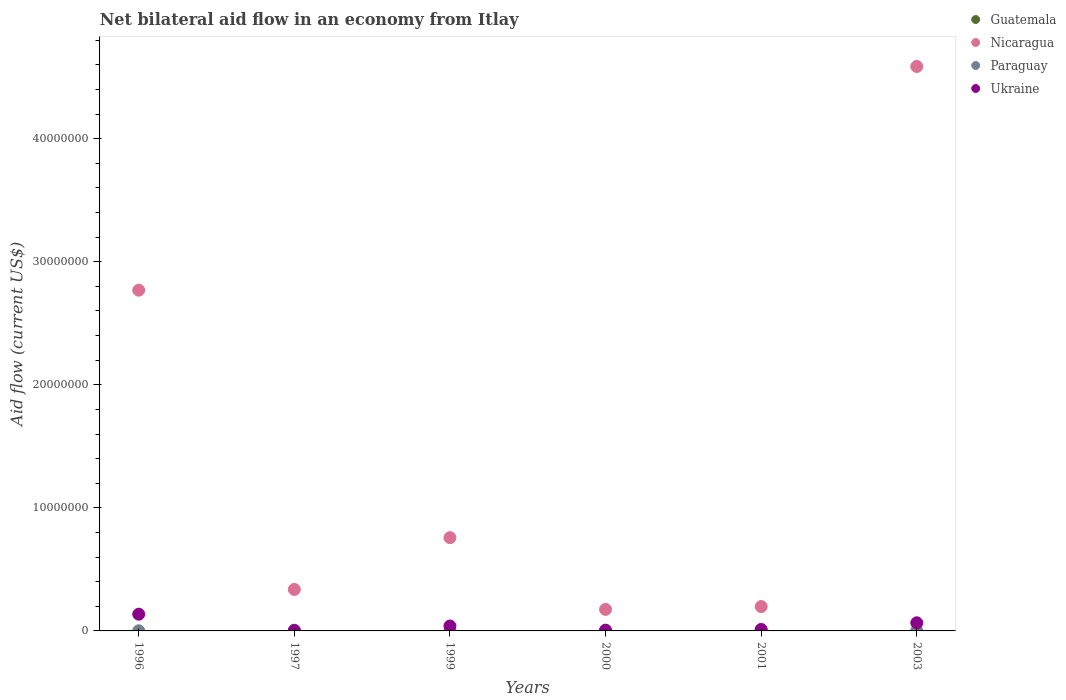How many different coloured dotlines are there?
Provide a succinct answer. 3. Is the number of dotlines equal to the number of legend labels?
Keep it short and to the point. No. What is the net bilateral aid flow in Paraguay in 1996?
Keep it short and to the point. 10000. In which year was the net bilateral aid flow in Ukraine maximum?
Make the answer very short. 1996. What is the total net bilateral aid flow in Nicaragua in the graph?
Provide a succinct answer. 8.82e+07. What is the difference between the net bilateral aid flow in Ukraine in 2003 and the net bilateral aid flow in Guatemala in 1997?
Give a very brief answer. 6.60e+05. What is the average net bilateral aid flow in Nicaragua per year?
Your response must be concise. 1.47e+07. In the year 1999, what is the difference between the net bilateral aid flow in Paraguay and net bilateral aid flow in Nicaragua?
Keep it short and to the point. -7.56e+06. In how many years, is the net bilateral aid flow in Nicaragua greater than 32000000 US$?
Ensure brevity in your answer.  1. Is the net bilateral aid flow in Paraguay in 1996 less than that in 2001?
Provide a succinct answer. Yes. Is the difference between the net bilateral aid flow in Paraguay in 2001 and 2003 greater than the difference between the net bilateral aid flow in Nicaragua in 2001 and 2003?
Provide a short and direct response. Yes. What is the difference between the highest and the second highest net bilateral aid flow in Nicaragua?
Keep it short and to the point. 1.82e+07. What is the difference between the highest and the lowest net bilateral aid flow in Nicaragua?
Make the answer very short. 4.41e+07. Is the sum of the net bilateral aid flow in Paraguay in 1999 and 2000 greater than the maximum net bilateral aid flow in Nicaragua across all years?
Keep it short and to the point. No. Is it the case that in every year, the sum of the net bilateral aid flow in Guatemala and net bilateral aid flow in Ukraine  is greater than the sum of net bilateral aid flow in Paraguay and net bilateral aid flow in Nicaragua?
Provide a short and direct response. No. Is the net bilateral aid flow in Nicaragua strictly greater than the net bilateral aid flow in Guatemala over the years?
Keep it short and to the point. Yes. How many dotlines are there?
Your answer should be compact. 3. What is the difference between two consecutive major ticks on the Y-axis?
Offer a terse response. 1.00e+07. Does the graph contain any zero values?
Ensure brevity in your answer.  Yes. What is the title of the graph?
Give a very brief answer. Net bilateral aid flow in an economy from Itlay. What is the label or title of the Y-axis?
Offer a very short reply. Aid flow (current US$). What is the Aid flow (current US$) of Guatemala in 1996?
Provide a short and direct response. 0. What is the Aid flow (current US$) of Nicaragua in 1996?
Keep it short and to the point. 2.77e+07. What is the Aid flow (current US$) in Paraguay in 1996?
Make the answer very short. 10000. What is the Aid flow (current US$) of Ukraine in 1996?
Provide a succinct answer. 1.36e+06. What is the Aid flow (current US$) in Guatemala in 1997?
Offer a terse response. 0. What is the Aid flow (current US$) of Nicaragua in 1997?
Keep it short and to the point. 3.37e+06. What is the Aid flow (current US$) of Paraguay in 1997?
Ensure brevity in your answer.  6.00e+04. What is the Aid flow (current US$) of Ukraine in 1997?
Provide a succinct answer. 3.00e+04. What is the Aid flow (current US$) of Nicaragua in 1999?
Your answer should be very brief. 7.58e+06. What is the Aid flow (current US$) of Paraguay in 1999?
Keep it short and to the point. 2.00e+04. What is the Aid flow (current US$) of Nicaragua in 2000?
Make the answer very short. 1.75e+06. What is the Aid flow (current US$) of Ukraine in 2000?
Your answer should be very brief. 6.00e+04. What is the Aid flow (current US$) in Guatemala in 2001?
Ensure brevity in your answer.  0. What is the Aid flow (current US$) in Nicaragua in 2001?
Your answer should be very brief. 1.98e+06. What is the Aid flow (current US$) of Ukraine in 2001?
Your response must be concise. 1.20e+05. What is the Aid flow (current US$) in Nicaragua in 2003?
Ensure brevity in your answer.  4.59e+07. What is the Aid flow (current US$) in Paraguay in 2003?
Make the answer very short. 2.00e+04. What is the Aid flow (current US$) of Ukraine in 2003?
Your response must be concise. 6.60e+05. Across all years, what is the maximum Aid flow (current US$) of Nicaragua?
Your response must be concise. 4.59e+07. Across all years, what is the maximum Aid flow (current US$) in Paraguay?
Keep it short and to the point. 6.00e+04. Across all years, what is the maximum Aid flow (current US$) in Ukraine?
Your answer should be very brief. 1.36e+06. Across all years, what is the minimum Aid flow (current US$) of Nicaragua?
Provide a succinct answer. 1.75e+06. Across all years, what is the minimum Aid flow (current US$) of Paraguay?
Make the answer very short. 10000. What is the total Aid flow (current US$) of Guatemala in the graph?
Offer a terse response. 0. What is the total Aid flow (current US$) in Nicaragua in the graph?
Your answer should be very brief. 8.82e+07. What is the total Aid flow (current US$) in Paraguay in the graph?
Your answer should be very brief. 1.90e+05. What is the total Aid flow (current US$) of Ukraine in the graph?
Provide a succinct answer. 2.63e+06. What is the difference between the Aid flow (current US$) of Nicaragua in 1996 and that in 1997?
Offer a very short reply. 2.43e+07. What is the difference between the Aid flow (current US$) in Ukraine in 1996 and that in 1997?
Your response must be concise. 1.33e+06. What is the difference between the Aid flow (current US$) in Nicaragua in 1996 and that in 1999?
Make the answer very short. 2.01e+07. What is the difference between the Aid flow (current US$) of Paraguay in 1996 and that in 1999?
Your answer should be compact. -10000. What is the difference between the Aid flow (current US$) of Ukraine in 1996 and that in 1999?
Give a very brief answer. 9.60e+05. What is the difference between the Aid flow (current US$) of Nicaragua in 1996 and that in 2000?
Provide a succinct answer. 2.59e+07. What is the difference between the Aid flow (current US$) of Paraguay in 1996 and that in 2000?
Keep it short and to the point. -2.00e+04. What is the difference between the Aid flow (current US$) in Ukraine in 1996 and that in 2000?
Keep it short and to the point. 1.30e+06. What is the difference between the Aid flow (current US$) of Nicaragua in 1996 and that in 2001?
Give a very brief answer. 2.57e+07. What is the difference between the Aid flow (current US$) of Ukraine in 1996 and that in 2001?
Offer a very short reply. 1.24e+06. What is the difference between the Aid flow (current US$) of Nicaragua in 1996 and that in 2003?
Ensure brevity in your answer.  -1.82e+07. What is the difference between the Aid flow (current US$) of Nicaragua in 1997 and that in 1999?
Give a very brief answer. -4.21e+06. What is the difference between the Aid flow (current US$) of Paraguay in 1997 and that in 1999?
Your answer should be compact. 4.00e+04. What is the difference between the Aid flow (current US$) of Ukraine in 1997 and that in 1999?
Give a very brief answer. -3.70e+05. What is the difference between the Aid flow (current US$) in Nicaragua in 1997 and that in 2000?
Give a very brief answer. 1.62e+06. What is the difference between the Aid flow (current US$) in Ukraine in 1997 and that in 2000?
Provide a succinct answer. -3.00e+04. What is the difference between the Aid flow (current US$) in Nicaragua in 1997 and that in 2001?
Your response must be concise. 1.39e+06. What is the difference between the Aid flow (current US$) of Paraguay in 1997 and that in 2001?
Your answer should be very brief. 10000. What is the difference between the Aid flow (current US$) of Nicaragua in 1997 and that in 2003?
Keep it short and to the point. -4.25e+07. What is the difference between the Aid flow (current US$) in Paraguay in 1997 and that in 2003?
Provide a succinct answer. 4.00e+04. What is the difference between the Aid flow (current US$) of Ukraine in 1997 and that in 2003?
Your answer should be compact. -6.30e+05. What is the difference between the Aid flow (current US$) of Nicaragua in 1999 and that in 2000?
Give a very brief answer. 5.83e+06. What is the difference between the Aid flow (current US$) in Paraguay in 1999 and that in 2000?
Make the answer very short. -10000. What is the difference between the Aid flow (current US$) of Ukraine in 1999 and that in 2000?
Ensure brevity in your answer.  3.40e+05. What is the difference between the Aid flow (current US$) in Nicaragua in 1999 and that in 2001?
Make the answer very short. 5.60e+06. What is the difference between the Aid flow (current US$) in Paraguay in 1999 and that in 2001?
Provide a short and direct response. -3.00e+04. What is the difference between the Aid flow (current US$) of Ukraine in 1999 and that in 2001?
Offer a very short reply. 2.80e+05. What is the difference between the Aid flow (current US$) of Nicaragua in 1999 and that in 2003?
Offer a very short reply. -3.83e+07. What is the difference between the Aid flow (current US$) of Paraguay in 1999 and that in 2003?
Provide a short and direct response. 0. What is the difference between the Aid flow (current US$) in Ukraine in 1999 and that in 2003?
Ensure brevity in your answer.  -2.60e+05. What is the difference between the Aid flow (current US$) in Nicaragua in 2000 and that in 2003?
Offer a very short reply. -4.41e+07. What is the difference between the Aid flow (current US$) in Ukraine in 2000 and that in 2003?
Offer a terse response. -6.00e+05. What is the difference between the Aid flow (current US$) in Nicaragua in 2001 and that in 2003?
Offer a very short reply. -4.39e+07. What is the difference between the Aid flow (current US$) in Paraguay in 2001 and that in 2003?
Your response must be concise. 3.00e+04. What is the difference between the Aid flow (current US$) of Ukraine in 2001 and that in 2003?
Your response must be concise. -5.40e+05. What is the difference between the Aid flow (current US$) in Nicaragua in 1996 and the Aid flow (current US$) in Paraguay in 1997?
Provide a succinct answer. 2.76e+07. What is the difference between the Aid flow (current US$) of Nicaragua in 1996 and the Aid flow (current US$) of Ukraine in 1997?
Keep it short and to the point. 2.77e+07. What is the difference between the Aid flow (current US$) of Nicaragua in 1996 and the Aid flow (current US$) of Paraguay in 1999?
Give a very brief answer. 2.77e+07. What is the difference between the Aid flow (current US$) in Nicaragua in 1996 and the Aid flow (current US$) in Ukraine in 1999?
Offer a very short reply. 2.73e+07. What is the difference between the Aid flow (current US$) in Paraguay in 1996 and the Aid flow (current US$) in Ukraine in 1999?
Your response must be concise. -3.90e+05. What is the difference between the Aid flow (current US$) in Nicaragua in 1996 and the Aid flow (current US$) in Paraguay in 2000?
Ensure brevity in your answer.  2.77e+07. What is the difference between the Aid flow (current US$) in Nicaragua in 1996 and the Aid flow (current US$) in Ukraine in 2000?
Offer a terse response. 2.76e+07. What is the difference between the Aid flow (current US$) in Paraguay in 1996 and the Aid flow (current US$) in Ukraine in 2000?
Provide a short and direct response. -5.00e+04. What is the difference between the Aid flow (current US$) of Nicaragua in 1996 and the Aid flow (current US$) of Paraguay in 2001?
Give a very brief answer. 2.76e+07. What is the difference between the Aid flow (current US$) in Nicaragua in 1996 and the Aid flow (current US$) in Ukraine in 2001?
Provide a succinct answer. 2.76e+07. What is the difference between the Aid flow (current US$) in Nicaragua in 1996 and the Aid flow (current US$) in Paraguay in 2003?
Provide a short and direct response. 2.77e+07. What is the difference between the Aid flow (current US$) of Nicaragua in 1996 and the Aid flow (current US$) of Ukraine in 2003?
Give a very brief answer. 2.70e+07. What is the difference between the Aid flow (current US$) in Paraguay in 1996 and the Aid flow (current US$) in Ukraine in 2003?
Provide a succinct answer. -6.50e+05. What is the difference between the Aid flow (current US$) in Nicaragua in 1997 and the Aid flow (current US$) in Paraguay in 1999?
Your answer should be compact. 3.35e+06. What is the difference between the Aid flow (current US$) in Nicaragua in 1997 and the Aid flow (current US$) in Ukraine in 1999?
Your answer should be very brief. 2.97e+06. What is the difference between the Aid flow (current US$) of Paraguay in 1997 and the Aid flow (current US$) of Ukraine in 1999?
Offer a very short reply. -3.40e+05. What is the difference between the Aid flow (current US$) of Nicaragua in 1997 and the Aid flow (current US$) of Paraguay in 2000?
Provide a short and direct response. 3.34e+06. What is the difference between the Aid flow (current US$) of Nicaragua in 1997 and the Aid flow (current US$) of Ukraine in 2000?
Offer a very short reply. 3.31e+06. What is the difference between the Aid flow (current US$) in Paraguay in 1997 and the Aid flow (current US$) in Ukraine in 2000?
Provide a short and direct response. 0. What is the difference between the Aid flow (current US$) of Nicaragua in 1997 and the Aid flow (current US$) of Paraguay in 2001?
Your answer should be compact. 3.32e+06. What is the difference between the Aid flow (current US$) of Nicaragua in 1997 and the Aid flow (current US$) of Ukraine in 2001?
Your response must be concise. 3.25e+06. What is the difference between the Aid flow (current US$) in Nicaragua in 1997 and the Aid flow (current US$) in Paraguay in 2003?
Give a very brief answer. 3.35e+06. What is the difference between the Aid flow (current US$) of Nicaragua in 1997 and the Aid flow (current US$) of Ukraine in 2003?
Offer a terse response. 2.71e+06. What is the difference between the Aid flow (current US$) of Paraguay in 1997 and the Aid flow (current US$) of Ukraine in 2003?
Offer a very short reply. -6.00e+05. What is the difference between the Aid flow (current US$) in Nicaragua in 1999 and the Aid flow (current US$) in Paraguay in 2000?
Your answer should be very brief. 7.55e+06. What is the difference between the Aid flow (current US$) of Nicaragua in 1999 and the Aid flow (current US$) of Ukraine in 2000?
Your response must be concise. 7.52e+06. What is the difference between the Aid flow (current US$) of Nicaragua in 1999 and the Aid flow (current US$) of Paraguay in 2001?
Offer a terse response. 7.53e+06. What is the difference between the Aid flow (current US$) of Nicaragua in 1999 and the Aid flow (current US$) of Ukraine in 2001?
Provide a short and direct response. 7.46e+06. What is the difference between the Aid flow (current US$) of Paraguay in 1999 and the Aid flow (current US$) of Ukraine in 2001?
Offer a terse response. -1.00e+05. What is the difference between the Aid flow (current US$) of Nicaragua in 1999 and the Aid flow (current US$) of Paraguay in 2003?
Offer a very short reply. 7.56e+06. What is the difference between the Aid flow (current US$) in Nicaragua in 1999 and the Aid flow (current US$) in Ukraine in 2003?
Keep it short and to the point. 6.92e+06. What is the difference between the Aid flow (current US$) in Paraguay in 1999 and the Aid flow (current US$) in Ukraine in 2003?
Give a very brief answer. -6.40e+05. What is the difference between the Aid flow (current US$) of Nicaragua in 2000 and the Aid flow (current US$) of Paraguay in 2001?
Offer a very short reply. 1.70e+06. What is the difference between the Aid flow (current US$) in Nicaragua in 2000 and the Aid flow (current US$) in Ukraine in 2001?
Provide a short and direct response. 1.63e+06. What is the difference between the Aid flow (current US$) in Paraguay in 2000 and the Aid flow (current US$) in Ukraine in 2001?
Offer a very short reply. -9.00e+04. What is the difference between the Aid flow (current US$) in Nicaragua in 2000 and the Aid flow (current US$) in Paraguay in 2003?
Offer a terse response. 1.73e+06. What is the difference between the Aid flow (current US$) in Nicaragua in 2000 and the Aid flow (current US$) in Ukraine in 2003?
Your answer should be very brief. 1.09e+06. What is the difference between the Aid flow (current US$) in Paraguay in 2000 and the Aid flow (current US$) in Ukraine in 2003?
Make the answer very short. -6.30e+05. What is the difference between the Aid flow (current US$) of Nicaragua in 2001 and the Aid flow (current US$) of Paraguay in 2003?
Ensure brevity in your answer.  1.96e+06. What is the difference between the Aid flow (current US$) in Nicaragua in 2001 and the Aid flow (current US$) in Ukraine in 2003?
Keep it short and to the point. 1.32e+06. What is the difference between the Aid flow (current US$) of Paraguay in 2001 and the Aid flow (current US$) of Ukraine in 2003?
Provide a short and direct response. -6.10e+05. What is the average Aid flow (current US$) in Guatemala per year?
Keep it short and to the point. 0. What is the average Aid flow (current US$) of Nicaragua per year?
Your response must be concise. 1.47e+07. What is the average Aid flow (current US$) of Paraguay per year?
Ensure brevity in your answer.  3.17e+04. What is the average Aid flow (current US$) of Ukraine per year?
Offer a terse response. 4.38e+05. In the year 1996, what is the difference between the Aid flow (current US$) of Nicaragua and Aid flow (current US$) of Paraguay?
Provide a succinct answer. 2.77e+07. In the year 1996, what is the difference between the Aid flow (current US$) of Nicaragua and Aid flow (current US$) of Ukraine?
Provide a succinct answer. 2.63e+07. In the year 1996, what is the difference between the Aid flow (current US$) in Paraguay and Aid flow (current US$) in Ukraine?
Your answer should be compact. -1.35e+06. In the year 1997, what is the difference between the Aid flow (current US$) in Nicaragua and Aid flow (current US$) in Paraguay?
Your answer should be compact. 3.31e+06. In the year 1997, what is the difference between the Aid flow (current US$) in Nicaragua and Aid flow (current US$) in Ukraine?
Make the answer very short. 3.34e+06. In the year 1999, what is the difference between the Aid flow (current US$) in Nicaragua and Aid flow (current US$) in Paraguay?
Your response must be concise. 7.56e+06. In the year 1999, what is the difference between the Aid flow (current US$) of Nicaragua and Aid flow (current US$) of Ukraine?
Provide a succinct answer. 7.18e+06. In the year 1999, what is the difference between the Aid flow (current US$) in Paraguay and Aid flow (current US$) in Ukraine?
Provide a short and direct response. -3.80e+05. In the year 2000, what is the difference between the Aid flow (current US$) of Nicaragua and Aid flow (current US$) of Paraguay?
Your answer should be compact. 1.72e+06. In the year 2000, what is the difference between the Aid flow (current US$) of Nicaragua and Aid flow (current US$) of Ukraine?
Give a very brief answer. 1.69e+06. In the year 2001, what is the difference between the Aid flow (current US$) of Nicaragua and Aid flow (current US$) of Paraguay?
Offer a very short reply. 1.93e+06. In the year 2001, what is the difference between the Aid flow (current US$) of Nicaragua and Aid flow (current US$) of Ukraine?
Give a very brief answer. 1.86e+06. In the year 2003, what is the difference between the Aid flow (current US$) in Nicaragua and Aid flow (current US$) in Paraguay?
Provide a short and direct response. 4.58e+07. In the year 2003, what is the difference between the Aid flow (current US$) in Nicaragua and Aid flow (current US$) in Ukraine?
Ensure brevity in your answer.  4.52e+07. In the year 2003, what is the difference between the Aid flow (current US$) in Paraguay and Aid flow (current US$) in Ukraine?
Provide a short and direct response. -6.40e+05. What is the ratio of the Aid flow (current US$) in Nicaragua in 1996 to that in 1997?
Provide a succinct answer. 8.22. What is the ratio of the Aid flow (current US$) of Ukraine in 1996 to that in 1997?
Keep it short and to the point. 45.33. What is the ratio of the Aid flow (current US$) in Nicaragua in 1996 to that in 1999?
Your answer should be compact. 3.65. What is the ratio of the Aid flow (current US$) of Paraguay in 1996 to that in 1999?
Offer a terse response. 0.5. What is the ratio of the Aid flow (current US$) in Nicaragua in 1996 to that in 2000?
Provide a succinct answer. 15.82. What is the ratio of the Aid flow (current US$) of Paraguay in 1996 to that in 2000?
Give a very brief answer. 0.33. What is the ratio of the Aid flow (current US$) in Ukraine in 1996 to that in 2000?
Make the answer very short. 22.67. What is the ratio of the Aid flow (current US$) in Nicaragua in 1996 to that in 2001?
Keep it short and to the point. 13.98. What is the ratio of the Aid flow (current US$) in Ukraine in 1996 to that in 2001?
Make the answer very short. 11.33. What is the ratio of the Aid flow (current US$) in Nicaragua in 1996 to that in 2003?
Provide a short and direct response. 0.6. What is the ratio of the Aid flow (current US$) of Ukraine in 1996 to that in 2003?
Keep it short and to the point. 2.06. What is the ratio of the Aid flow (current US$) of Nicaragua in 1997 to that in 1999?
Your response must be concise. 0.44. What is the ratio of the Aid flow (current US$) of Ukraine in 1997 to that in 1999?
Make the answer very short. 0.07. What is the ratio of the Aid flow (current US$) of Nicaragua in 1997 to that in 2000?
Keep it short and to the point. 1.93. What is the ratio of the Aid flow (current US$) in Nicaragua in 1997 to that in 2001?
Give a very brief answer. 1.7. What is the ratio of the Aid flow (current US$) of Paraguay in 1997 to that in 2001?
Provide a succinct answer. 1.2. What is the ratio of the Aid flow (current US$) in Ukraine in 1997 to that in 2001?
Provide a short and direct response. 0.25. What is the ratio of the Aid flow (current US$) of Nicaragua in 1997 to that in 2003?
Ensure brevity in your answer.  0.07. What is the ratio of the Aid flow (current US$) of Ukraine in 1997 to that in 2003?
Offer a very short reply. 0.05. What is the ratio of the Aid flow (current US$) of Nicaragua in 1999 to that in 2000?
Your answer should be compact. 4.33. What is the ratio of the Aid flow (current US$) of Paraguay in 1999 to that in 2000?
Ensure brevity in your answer.  0.67. What is the ratio of the Aid flow (current US$) of Nicaragua in 1999 to that in 2001?
Ensure brevity in your answer.  3.83. What is the ratio of the Aid flow (current US$) of Nicaragua in 1999 to that in 2003?
Ensure brevity in your answer.  0.17. What is the ratio of the Aid flow (current US$) of Ukraine in 1999 to that in 2003?
Keep it short and to the point. 0.61. What is the ratio of the Aid flow (current US$) of Nicaragua in 2000 to that in 2001?
Offer a terse response. 0.88. What is the ratio of the Aid flow (current US$) of Paraguay in 2000 to that in 2001?
Keep it short and to the point. 0.6. What is the ratio of the Aid flow (current US$) in Nicaragua in 2000 to that in 2003?
Provide a succinct answer. 0.04. What is the ratio of the Aid flow (current US$) of Paraguay in 2000 to that in 2003?
Give a very brief answer. 1.5. What is the ratio of the Aid flow (current US$) in Ukraine in 2000 to that in 2003?
Your answer should be compact. 0.09. What is the ratio of the Aid flow (current US$) in Nicaragua in 2001 to that in 2003?
Your answer should be compact. 0.04. What is the ratio of the Aid flow (current US$) of Paraguay in 2001 to that in 2003?
Provide a short and direct response. 2.5. What is the ratio of the Aid flow (current US$) in Ukraine in 2001 to that in 2003?
Your answer should be very brief. 0.18. What is the difference between the highest and the second highest Aid flow (current US$) of Nicaragua?
Offer a very short reply. 1.82e+07. What is the difference between the highest and the second highest Aid flow (current US$) in Paraguay?
Keep it short and to the point. 10000. What is the difference between the highest and the second highest Aid flow (current US$) in Ukraine?
Provide a short and direct response. 7.00e+05. What is the difference between the highest and the lowest Aid flow (current US$) of Nicaragua?
Provide a succinct answer. 4.41e+07. What is the difference between the highest and the lowest Aid flow (current US$) of Ukraine?
Ensure brevity in your answer.  1.33e+06. 